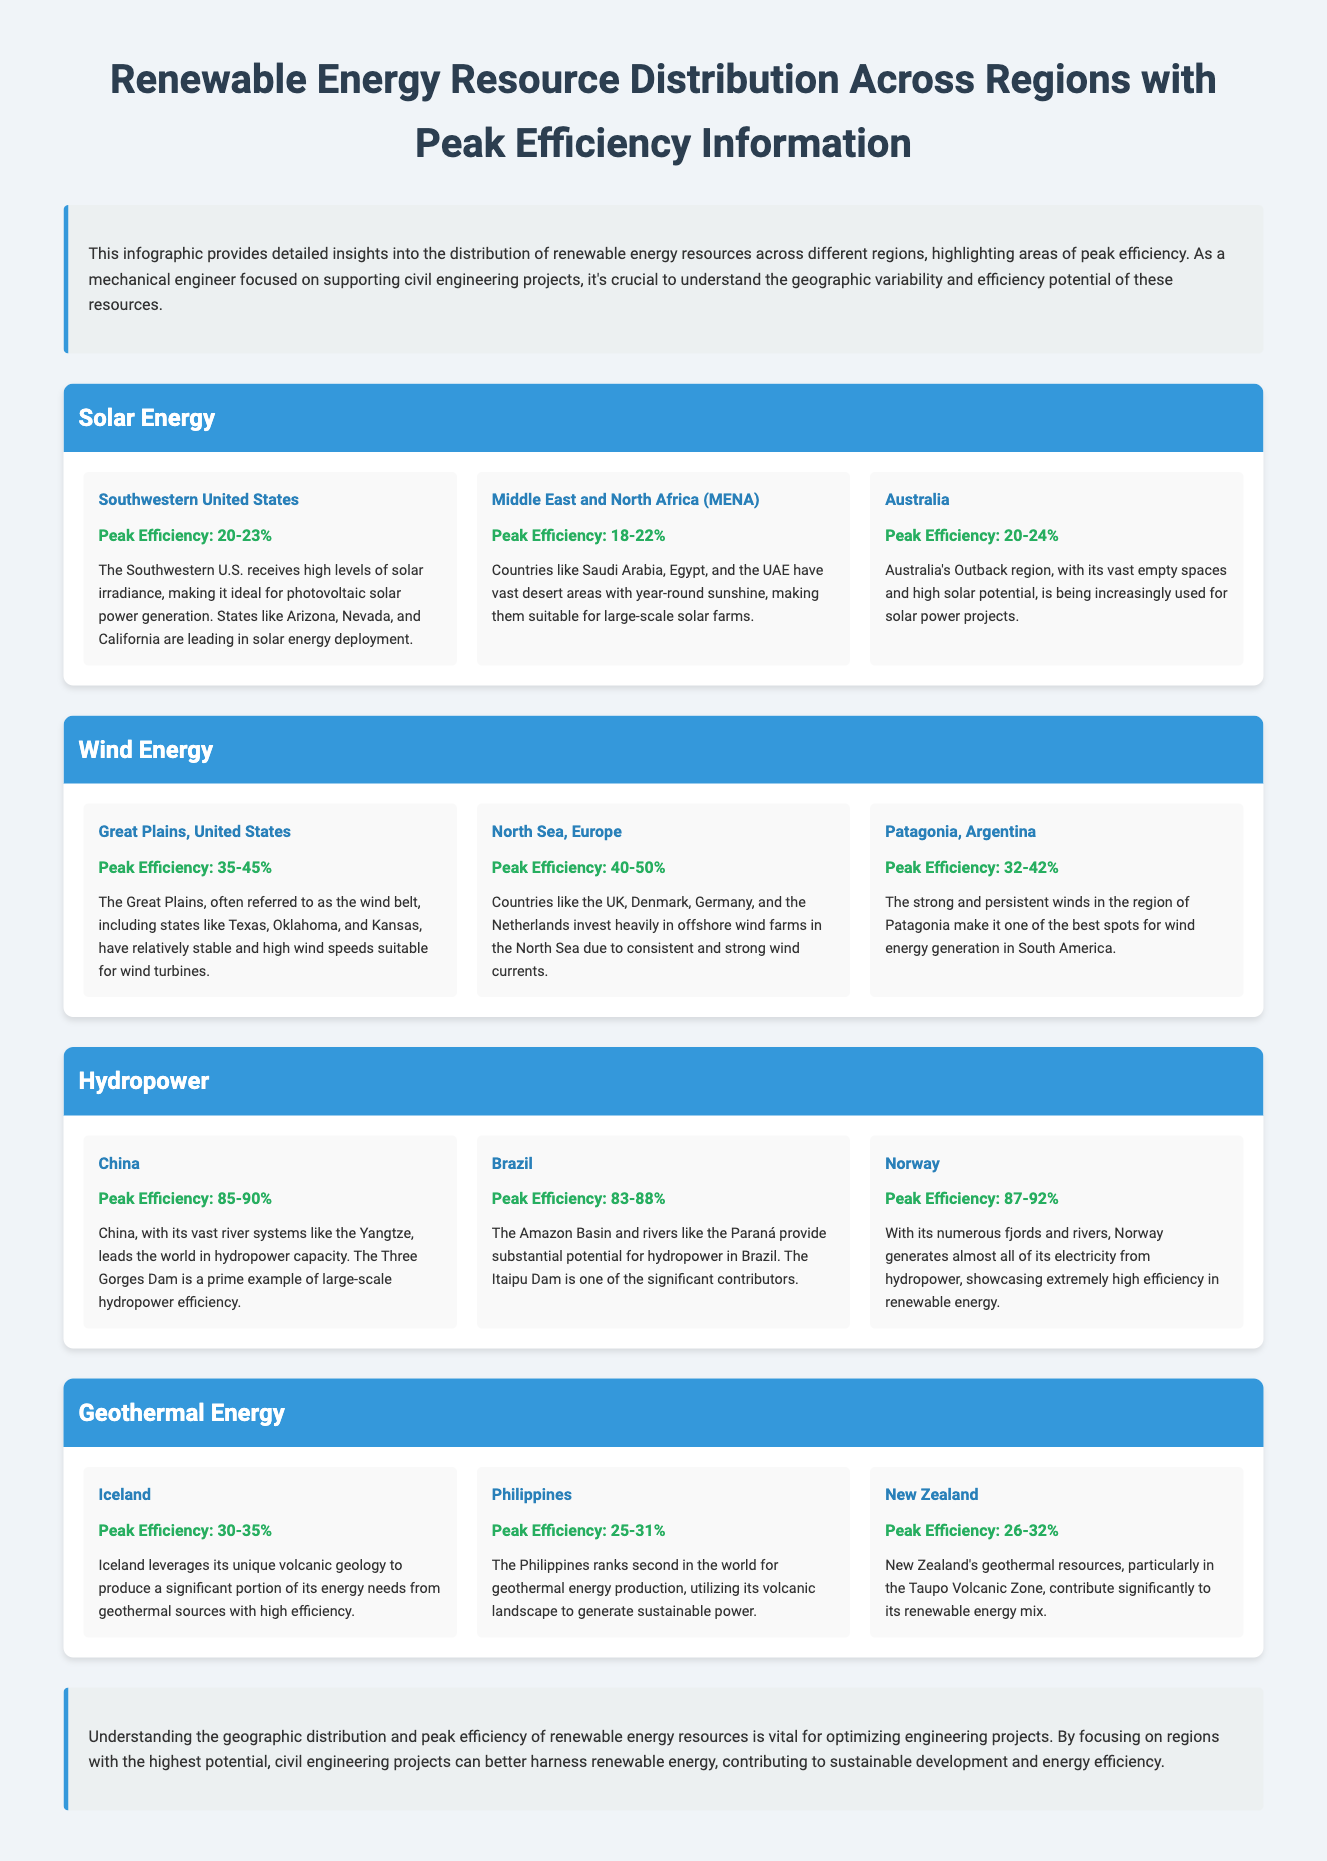what is the peak efficiency of solar energy in Australia? The document states that the peak efficiency of solar energy in Australia is 20-24%.
Answer: 20-24% which region has the highest peak efficiency for hydropower? According to the infographic, Norway has the highest peak efficiency for hydropower at 87-92%.
Answer: 87-92% what is the main factor contributing to the suitability of the Great Plains for wind energy? The document notes that the Great Plains have relatively stable and high wind speeds suitable for wind turbines.
Answer: High wind speeds which country is ranked second in the world for geothermal energy production? The infographic mentions that the Philippines ranks second in the world for geothermal energy production.
Answer: Philippines what type of renewable energy is primarily generated in Patagonia, Argentina? The document states that Patagonia is known for wind energy generation.
Answer: Wind energy how does the peak efficiency of China’s hydropower compare to Brazil’s hydropower efficiency? The infographic illustrates that China has a peak efficiency of 85-90%, while Brazil has 83-88%.
Answer: China is higher which region has the lowest peak efficiency for geothermal energy? The document indicates that the Philippines has the lowest peak efficiency for geothermal energy at 25-31%.
Answer: 25-31% what natural feature is noted as a contributing factor for Iceland’s geothermal energy production? The document highlights Iceland's unique volcanic geology as a key factor in its geothermal energy production.
Answer: Volcanic geology what is the overall purpose of the infographic according to the conclusion? The conclusion states the purpose of the infographic is to optimize engineering projects by understanding renewable energy resources.
Answer: Optimize engineering projects 